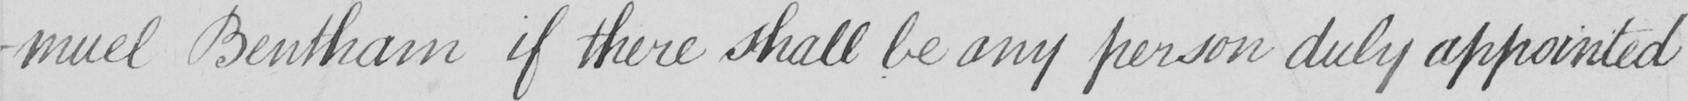Please transcribe the handwritten text in this image. -muel Bentham if there shall be any person duly appointed 